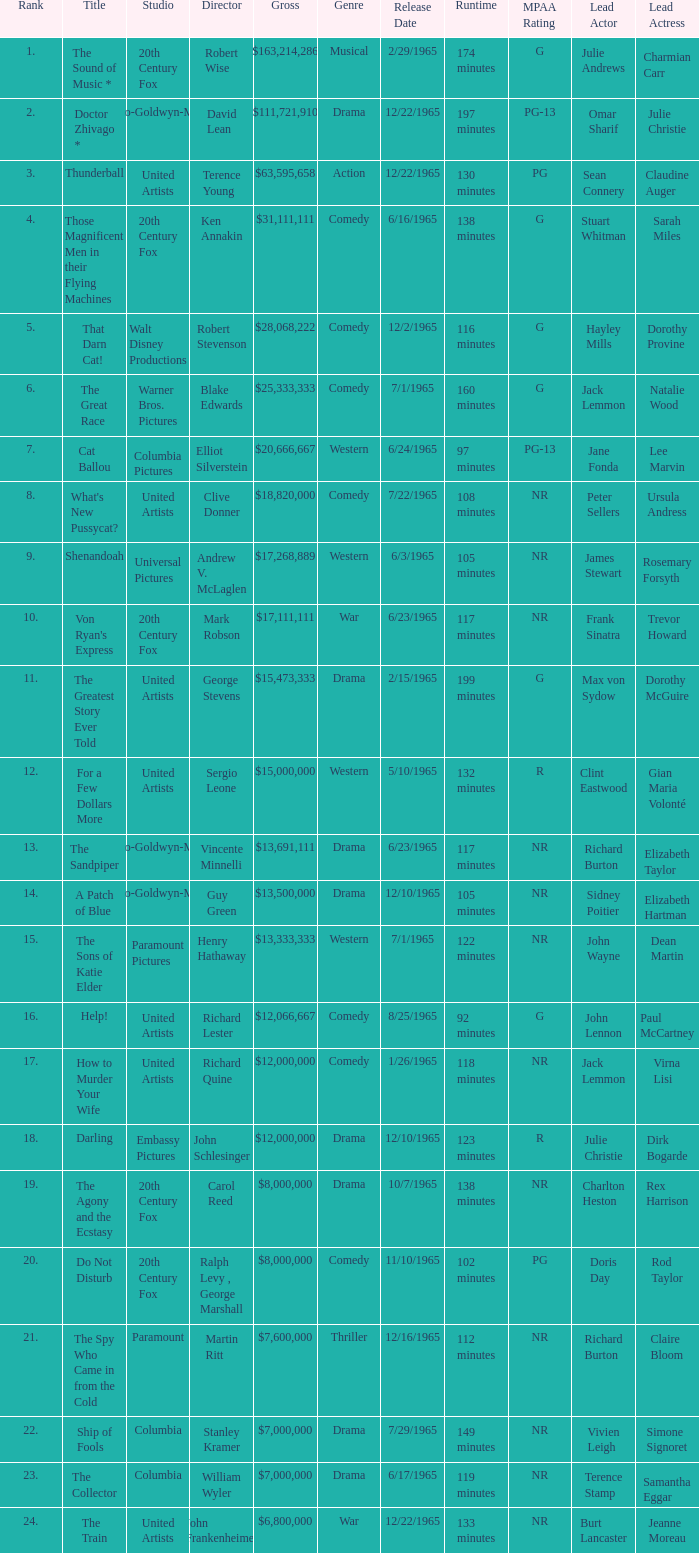What is Studio, when Title is "Do Not Disturb"? 20th Century Fox. 